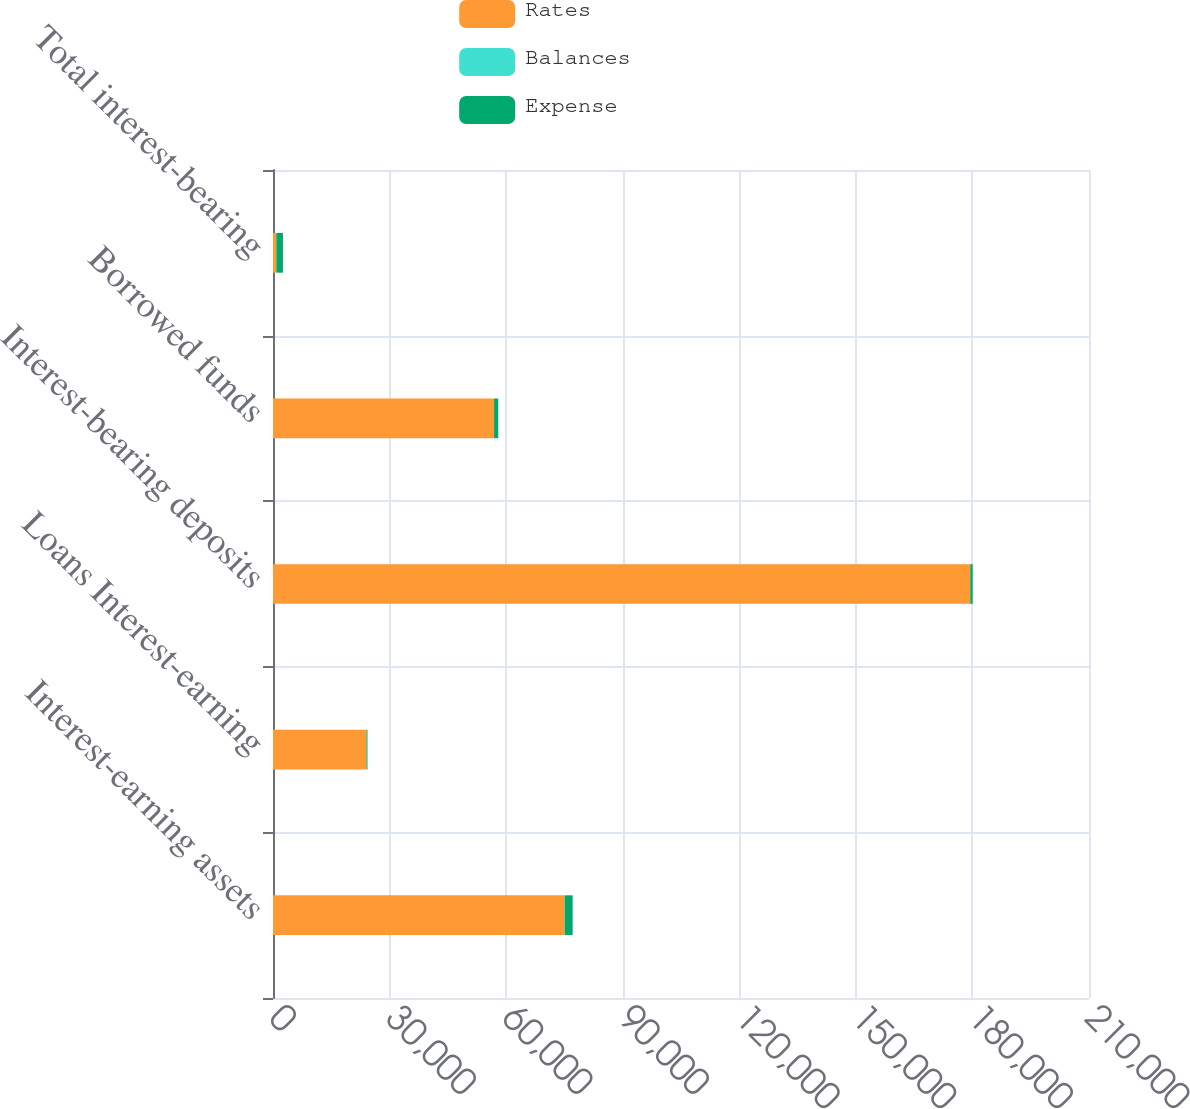<chart> <loc_0><loc_0><loc_500><loc_500><stacked_bar_chart><ecel><fcel>Interest-earning assets<fcel>Loans Interest-earning<fcel>Interest-bearing deposits<fcel>Borrowed funds<fcel>Total interest-bearing<nl><fcel>Rates<fcel>75057<fcel>24043<fcel>179447<fcel>56889<fcel>853<nl><fcel>Balances<fcel>2.74<fcel>1.11<fcel>0.35<fcel>1.9<fcel>0.72<nl><fcel>Expense<fcel>2059<fcel>267<fcel>623<fcel>1083<fcel>1706<nl></chart> 